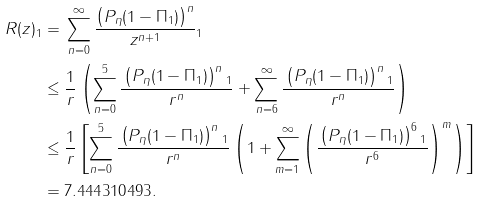Convert formula to latex. <formula><loc_0><loc_0><loc_500><loc_500>\| R ( z ) \| _ { 1 } & = \| \sum _ { n = 0 } ^ { \infty } \frac { \left ( P _ { \eta } ( { 1 } - \Pi _ { 1 } ) \right ) ^ { n } } { z ^ { n + 1 } } \| _ { 1 } \\ & \leq \frac { 1 } { r } \left ( \sum _ { n = 0 } ^ { 5 } \frac { \| \left ( P _ { \eta } ( { 1 } - \Pi _ { 1 } ) \right ) ^ { n } \| _ { 1 } } { r ^ { n } } + \sum _ { n = 6 } ^ { \infty } \frac { \| \left ( P _ { \eta } ( { 1 } - \Pi _ { 1 } ) \right ) ^ { n } \| _ { 1 } } { r ^ { n } } \right ) \\ & \leq \frac { 1 } { r } \left [ \sum _ { n = 0 } ^ { 5 } \frac { \| \left ( P _ { \eta } ( { 1 } - \Pi _ { 1 } ) \right ) ^ { n } \| _ { 1 } } { r ^ { n } } \left ( 1 + \sum _ { m = 1 } ^ { \infty } \left ( \frac { \| \left ( P _ { \eta } ( { 1 } - \Pi _ { 1 } ) \right ) ^ { 6 } \| _ { 1 } } { r ^ { 6 } } \right ) ^ { m } \right ) \right ] \\ & = 7 . 4 4 4 3 1 0 4 9 3 .</formula> 